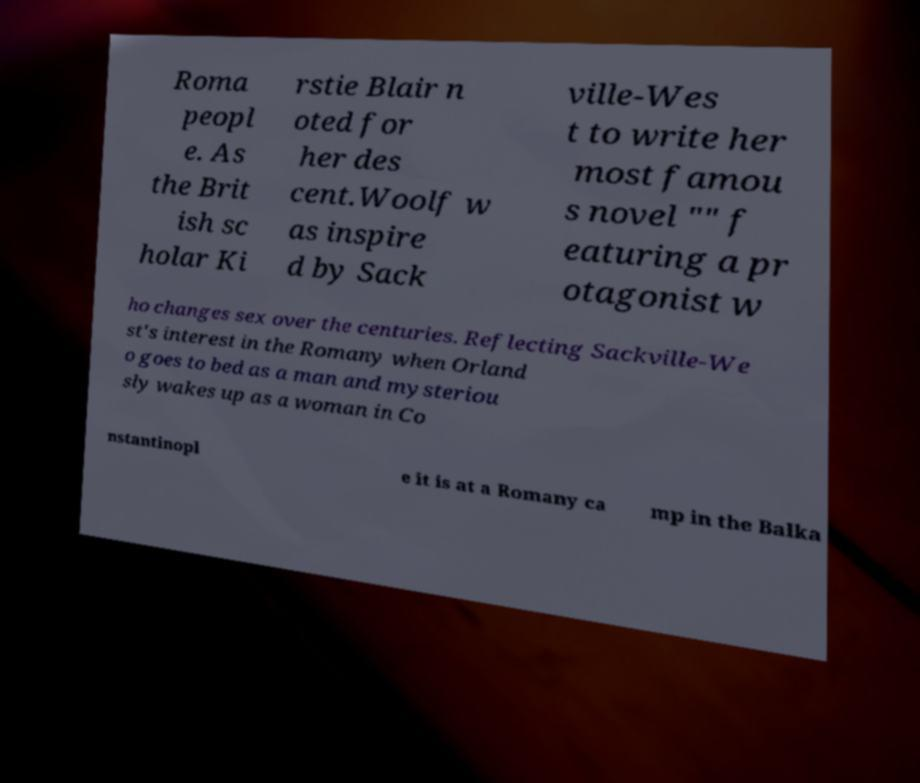What messages or text are displayed in this image? I need them in a readable, typed format. Roma peopl e. As the Brit ish sc holar Ki rstie Blair n oted for her des cent.Woolf w as inspire d by Sack ville-Wes t to write her most famou s novel "" f eaturing a pr otagonist w ho changes sex over the centuries. Reflecting Sackville-We st's interest in the Romany when Orland o goes to bed as a man and mysteriou sly wakes up as a woman in Co nstantinopl e it is at a Romany ca mp in the Balka 